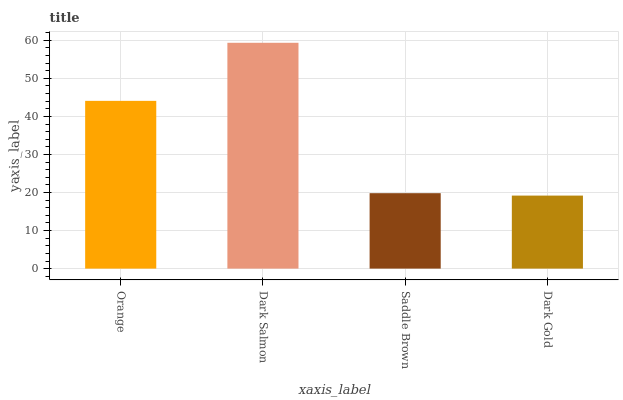Is Dark Gold the minimum?
Answer yes or no. Yes. Is Dark Salmon the maximum?
Answer yes or no. Yes. Is Saddle Brown the minimum?
Answer yes or no. No. Is Saddle Brown the maximum?
Answer yes or no. No. Is Dark Salmon greater than Saddle Brown?
Answer yes or no. Yes. Is Saddle Brown less than Dark Salmon?
Answer yes or no. Yes. Is Saddle Brown greater than Dark Salmon?
Answer yes or no. No. Is Dark Salmon less than Saddle Brown?
Answer yes or no. No. Is Orange the high median?
Answer yes or no. Yes. Is Saddle Brown the low median?
Answer yes or no. Yes. Is Dark Gold the high median?
Answer yes or no. No. Is Dark Gold the low median?
Answer yes or no. No. 